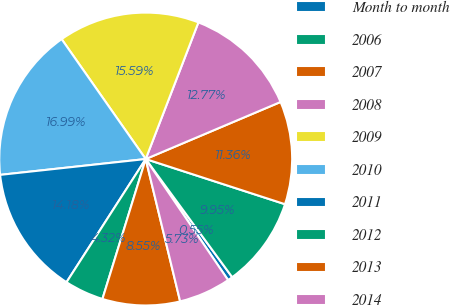<chart> <loc_0><loc_0><loc_500><loc_500><pie_chart><fcel>Month to month<fcel>2006<fcel>2007<fcel>2008<fcel>2009<fcel>2010<fcel>2011<fcel>2012<fcel>2013<fcel>2014<nl><fcel>0.55%<fcel>9.95%<fcel>11.36%<fcel>12.77%<fcel>15.59%<fcel>16.99%<fcel>14.18%<fcel>4.32%<fcel>8.55%<fcel>5.73%<nl></chart> 